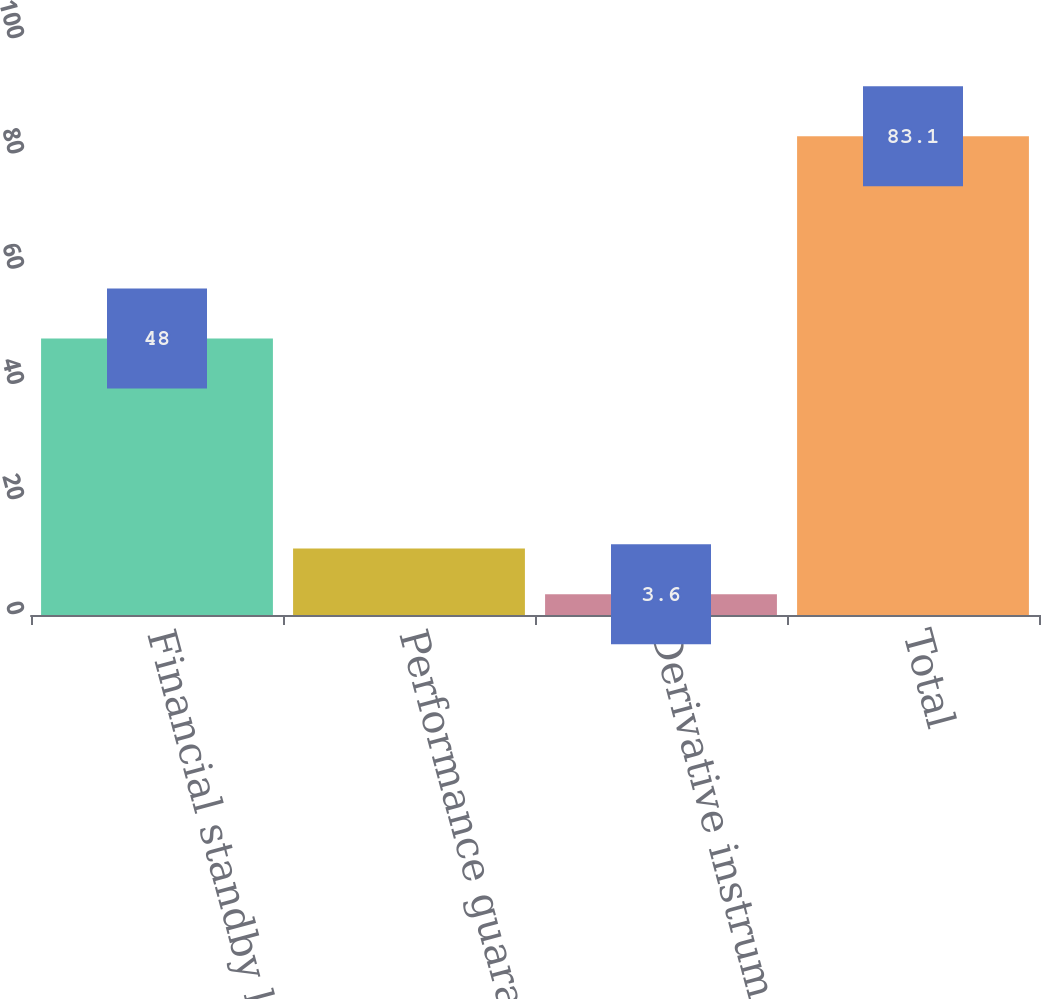Convert chart to OTSL. <chart><loc_0><loc_0><loc_500><loc_500><bar_chart><fcel>Financial standby letters of<fcel>Performance guarantees<fcel>Derivative instruments<fcel>Total<nl><fcel>48<fcel>11.55<fcel>3.6<fcel>83.1<nl></chart> 